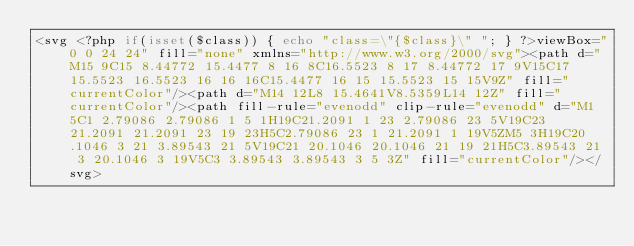Convert code to text. <code><loc_0><loc_0><loc_500><loc_500><_PHP_><svg <?php if(isset($class)) { echo "class=\"{$class}\" "; } ?>viewBox="0 0 24 24" fill="none" xmlns="http://www.w3.org/2000/svg"><path d="M15 9C15 8.44772 15.4477 8 16 8C16.5523 8 17 8.44772 17 9V15C17 15.5523 16.5523 16 16 16C15.4477 16 15 15.5523 15 15V9Z" fill="currentColor"/><path d="M14 12L8 15.4641V8.5359L14 12Z" fill="currentColor"/><path fill-rule="evenodd" clip-rule="evenodd" d="M1 5C1 2.79086 2.79086 1 5 1H19C21.2091 1 23 2.79086 23 5V19C23 21.2091 21.2091 23 19 23H5C2.79086 23 1 21.2091 1 19V5ZM5 3H19C20.1046 3 21 3.89543 21 5V19C21 20.1046 20.1046 21 19 21H5C3.89543 21 3 20.1046 3 19V5C3 3.89543 3.89543 3 5 3Z" fill="currentColor"/></svg></code> 